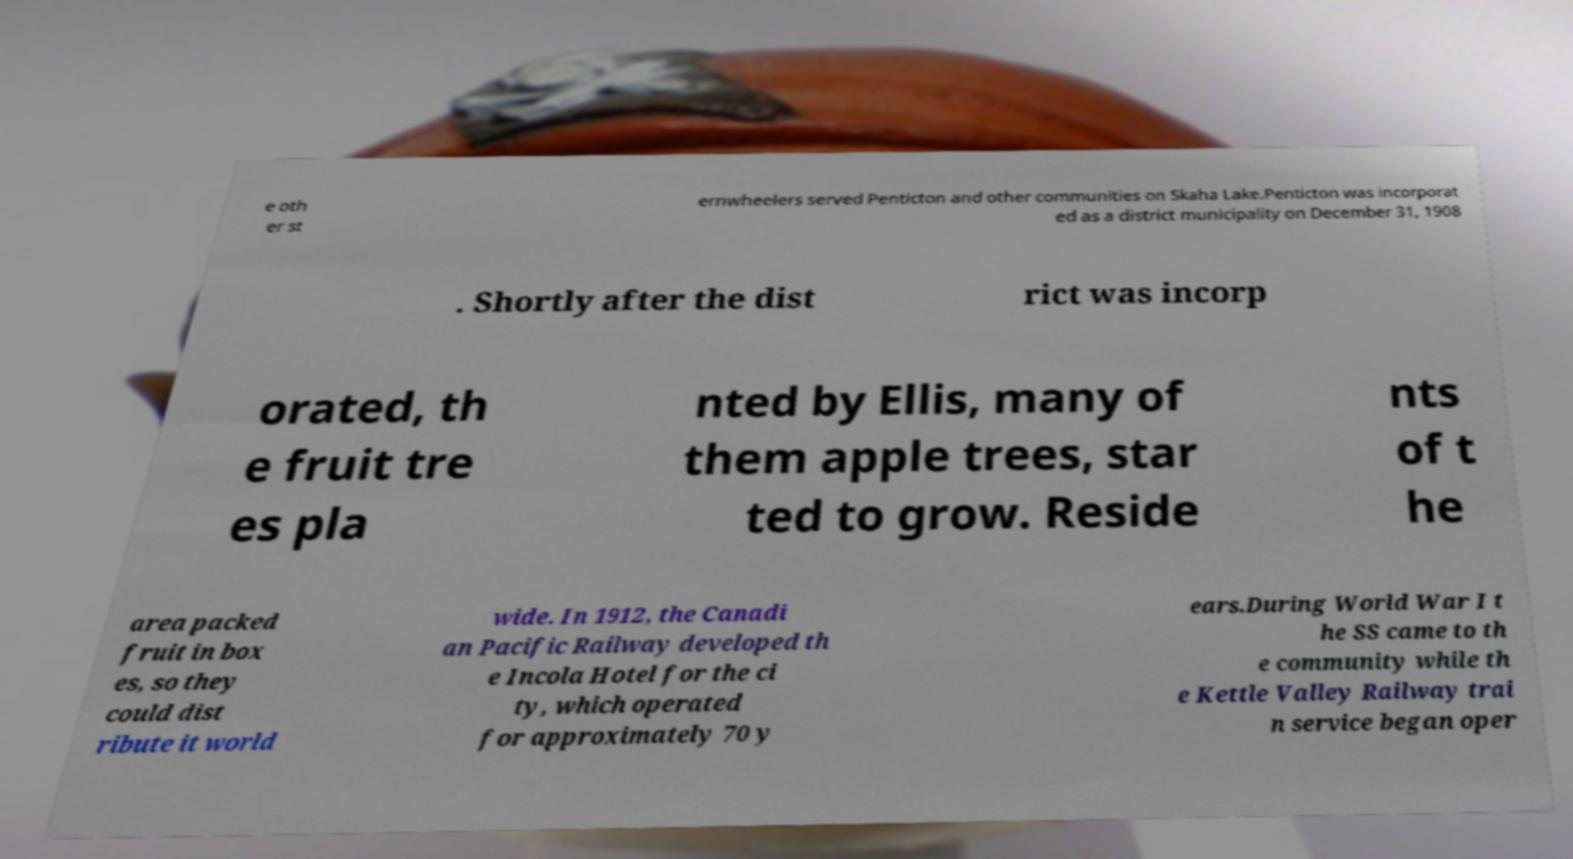I need the written content from this picture converted into text. Can you do that? e oth er st ernwheelers served Penticton and other communities on Skaha Lake.Penticton was incorporat ed as a district municipality on December 31, 1908 . Shortly after the dist rict was incorp orated, th e fruit tre es pla nted by Ellis, many of them apple trees, star ted to grow. Reside nts of t he area packed fruit in box es, so they could dist ribute it world wide. In 1912, the Canadi an Pacific Railway developed th e Incola Hotel for the ci ty, which operated for approximately 70 y ears.During World War I t he SS came to th e community while th e Kettle Valley Railway trai n service began oper 